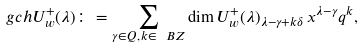Convert formula to latex. <formula><loc_0><loc_0><loc_500><loc_500>\ g c h U _ { w } ^ { + } ( \lambda ) \colon = \sum _ { \gamma \in Q , \, k \in \ B Z } \dim U _ { w } ^ { + } ( \lambda ) _ { \lambda - \gamma + k \delta } \, x ^ { \lambda - \gamma } q ^ { k } ,</formula> 